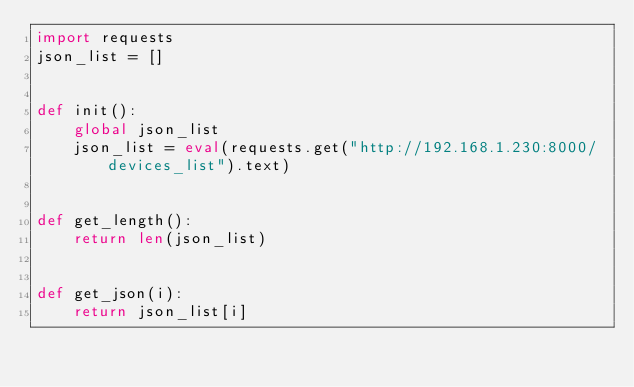Convert code to text. <code><loc_0><loc_0><loc_500><loc_500><_Python_>import requests
json_list = []


def init():
    global json_list
    json_list = eval(requests.get("http://192.168.1.230:8000/devices_list").text)


def get_length():
    return len(json_list)


def get_json(i):
    return json_list[i]
</code> 